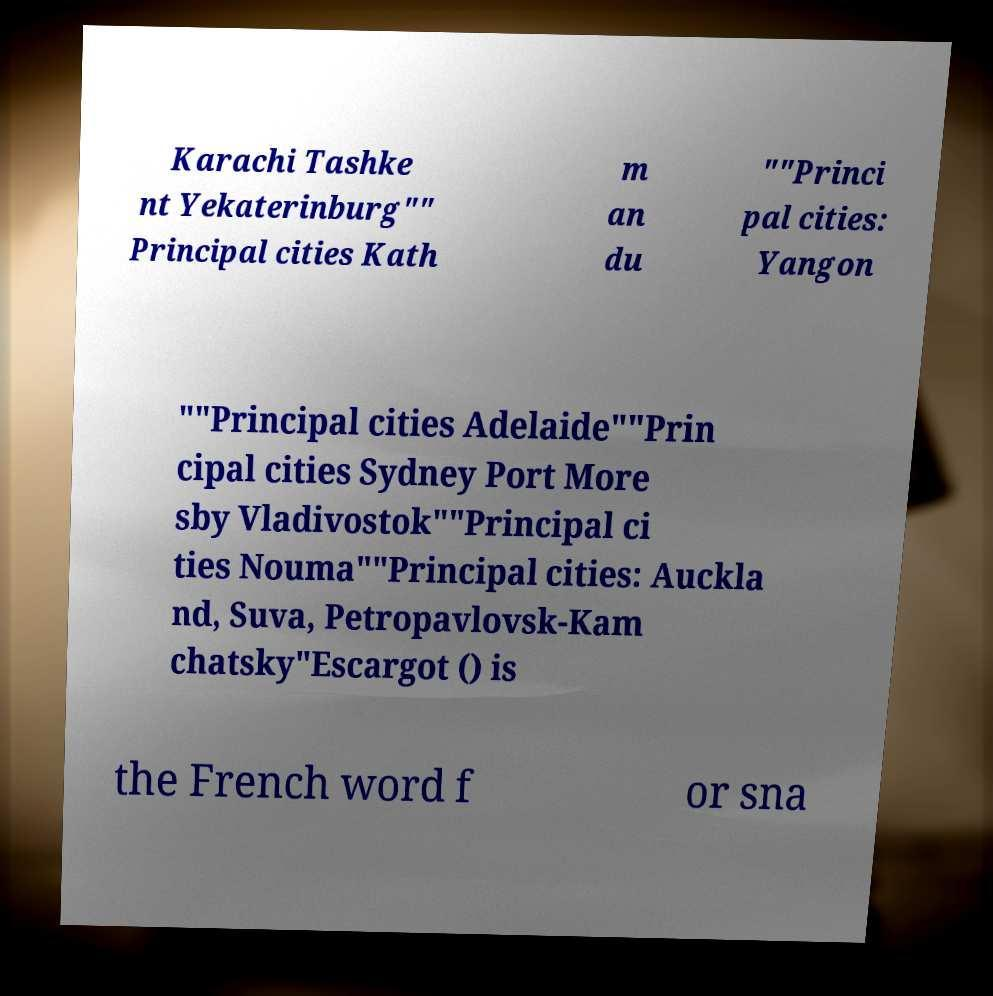Can you accurately transcribe the text from the provided image for me? Karachi Tashke nt Yekaterinburg"" Principal cities Kath m an du ""Princi pal cities: Yangon ""Principal cities Adelaide""Prin cipal cities Sydney Port More sby Vladivostok""Principal ci ties Nouma""Principal cities: Auckla nd, Suva, Petropavlovsk-Kam chatsky"Escargot () is the French word f or sna 